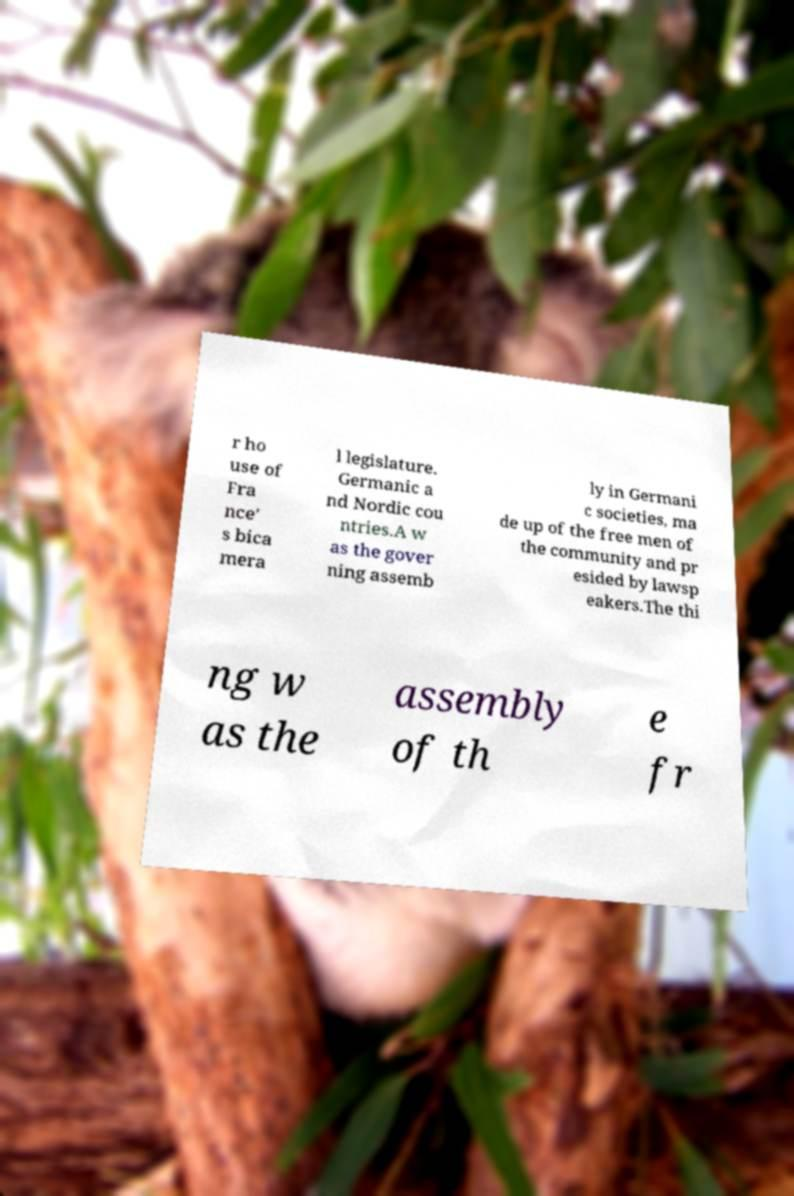What messages or text are displayed in this image? I need them in a readable, typed format. r ho use of Fra nce' s bica mera l legislature. Germanic a nd Nordic cou ntries.A w as the gover ning assemb ly in Germani c societies, ma de up of the free men of the community and pr esided by lawsp eakers.The thi ng w as the assembly of th e fr 